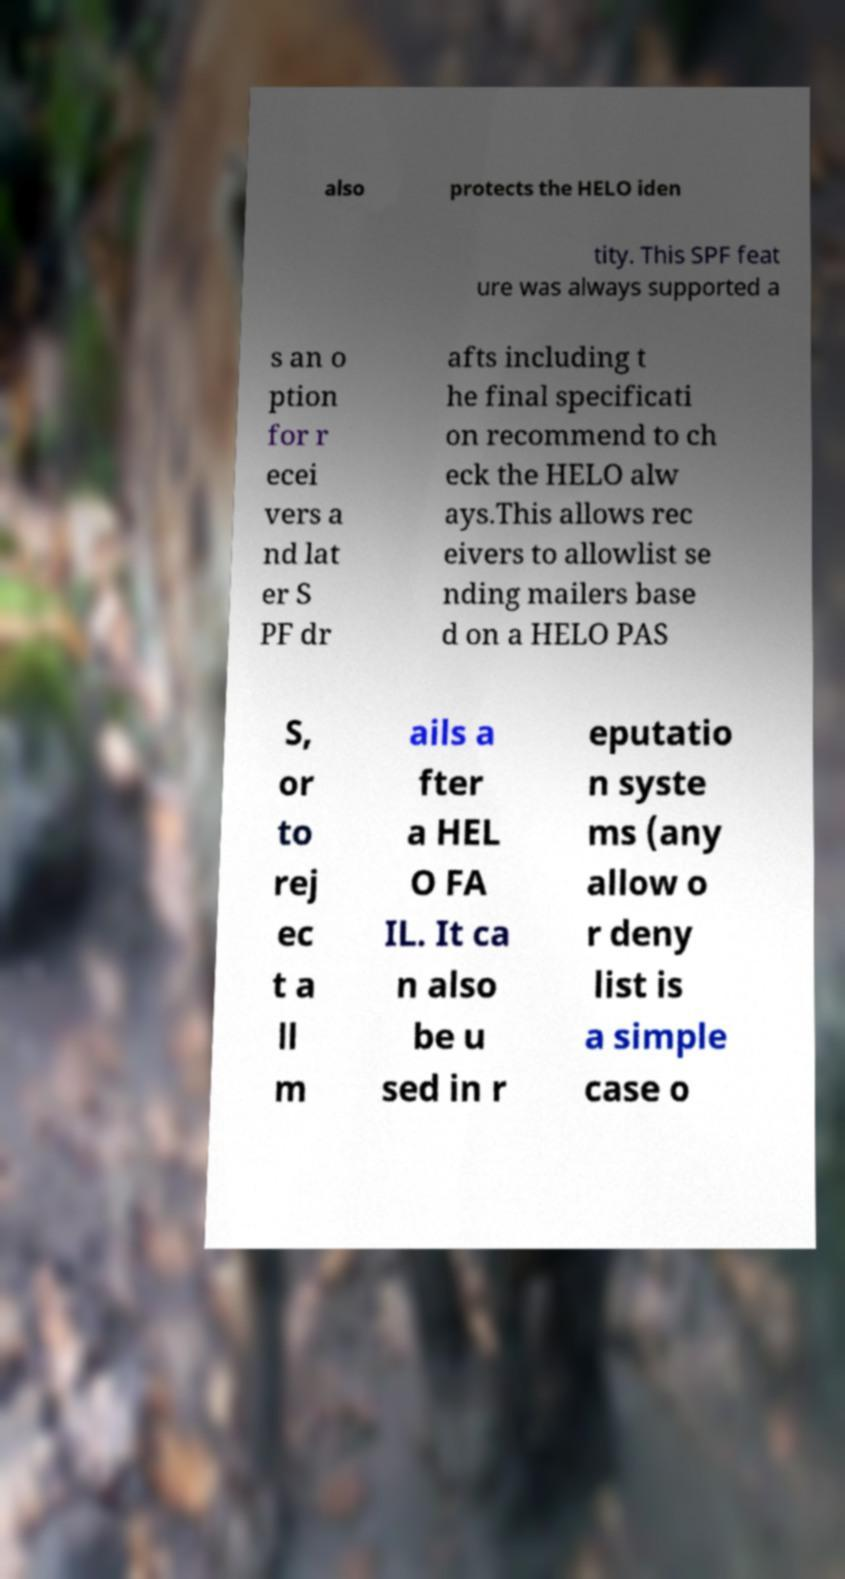Can you accurately transcribe the text from the provided image for me? also protects the HELO iden tity. This SPF feat ure was always supported a s an o ption for r ecei vers a nd lat er S PF dr afts including t he final specificati on recommend to ch eck the HELO alw ays.This allows rec eivers to allowlist se nding mailers base d on a HELO PAS S, or to rej ec t a ll m ails a fter a HEL O FA IL. It ca n also be u sed in r eputatio n syste ms (any allow o r deny list is a simple case o 